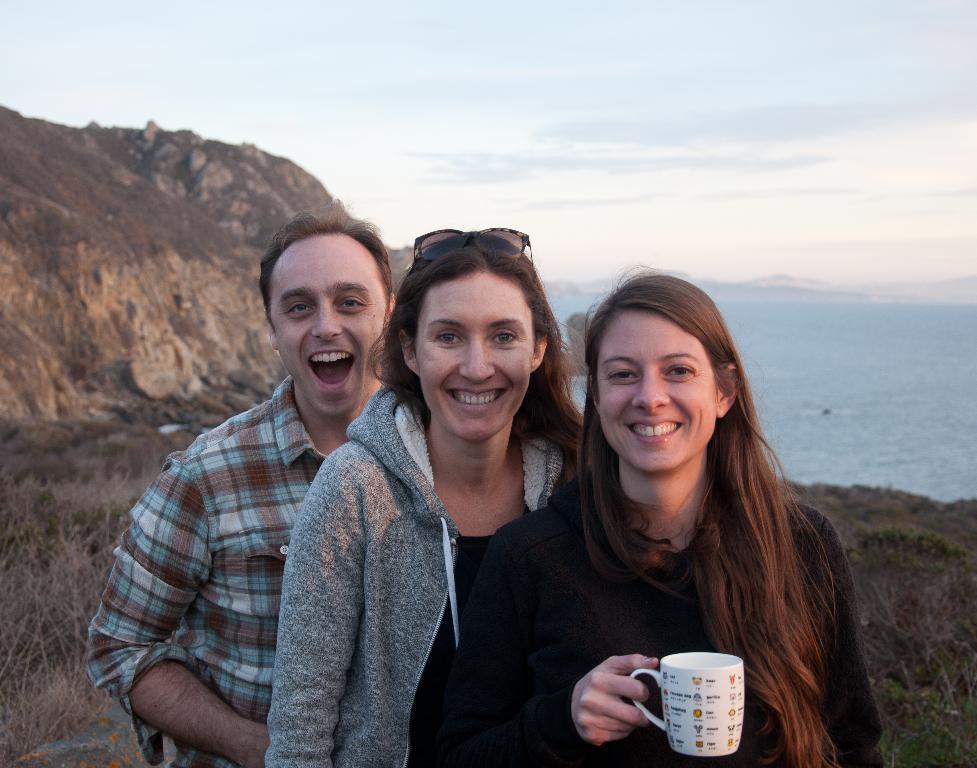Describe this image in one or two sentences. In this image, In the center there are three people standing and in the background there is a water which is blue color, In the left side of the image there is a mountain which is in brown color, In the top of the image there is sky which is in white color. 